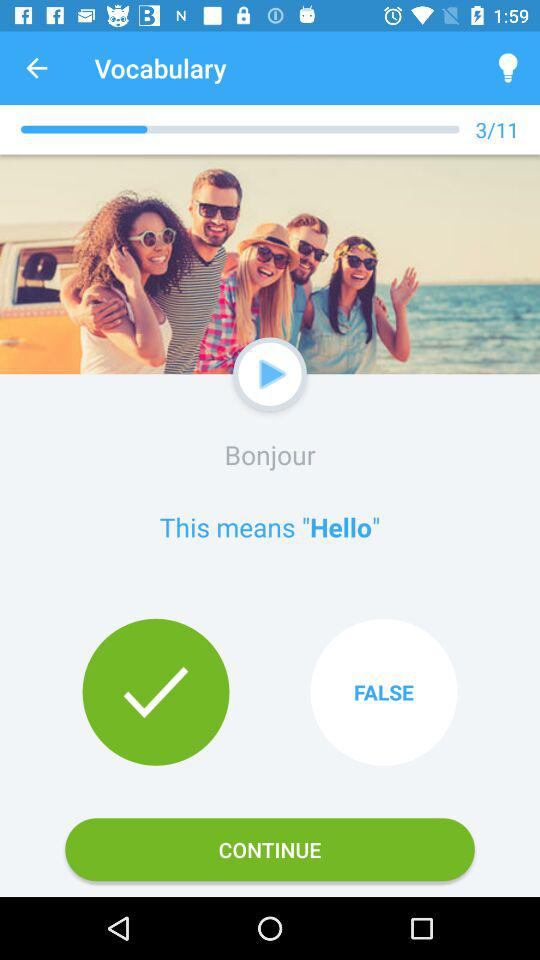On which question number am I? You are on the third question. 